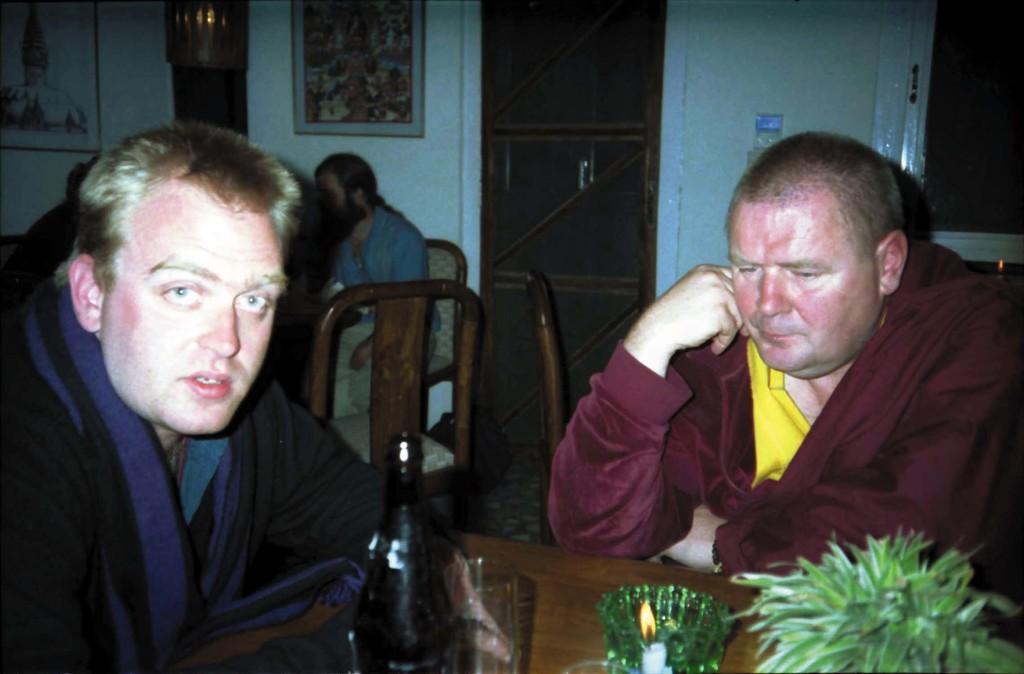How would you summarize this image in a sentence or two? In this image we can see two persons sitting in front of the table and on the table we can see a bottle, glass, bowl, plant and a candle with the flame. In the background we can see the door, window, frames attached to the wall. We can also see the empty chair and also persons sitting on the chairs. 